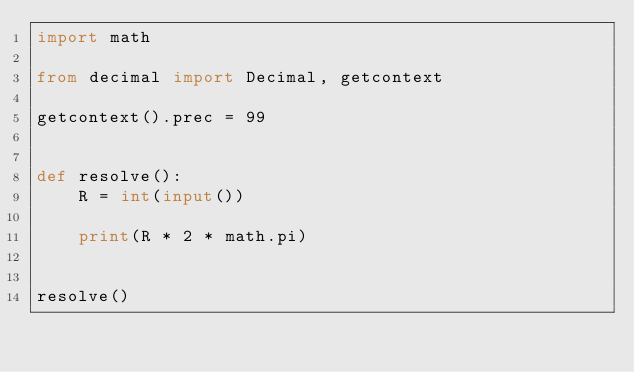<code> <loc_0><loc_0><loc_500><loc_500><_Python_>import math

from decimal import Decimal, getcontext

getcontext().prec = 99


def resolve():
    R = int(input())

    print(R * 2 * math.pi)


resolve()</code> 